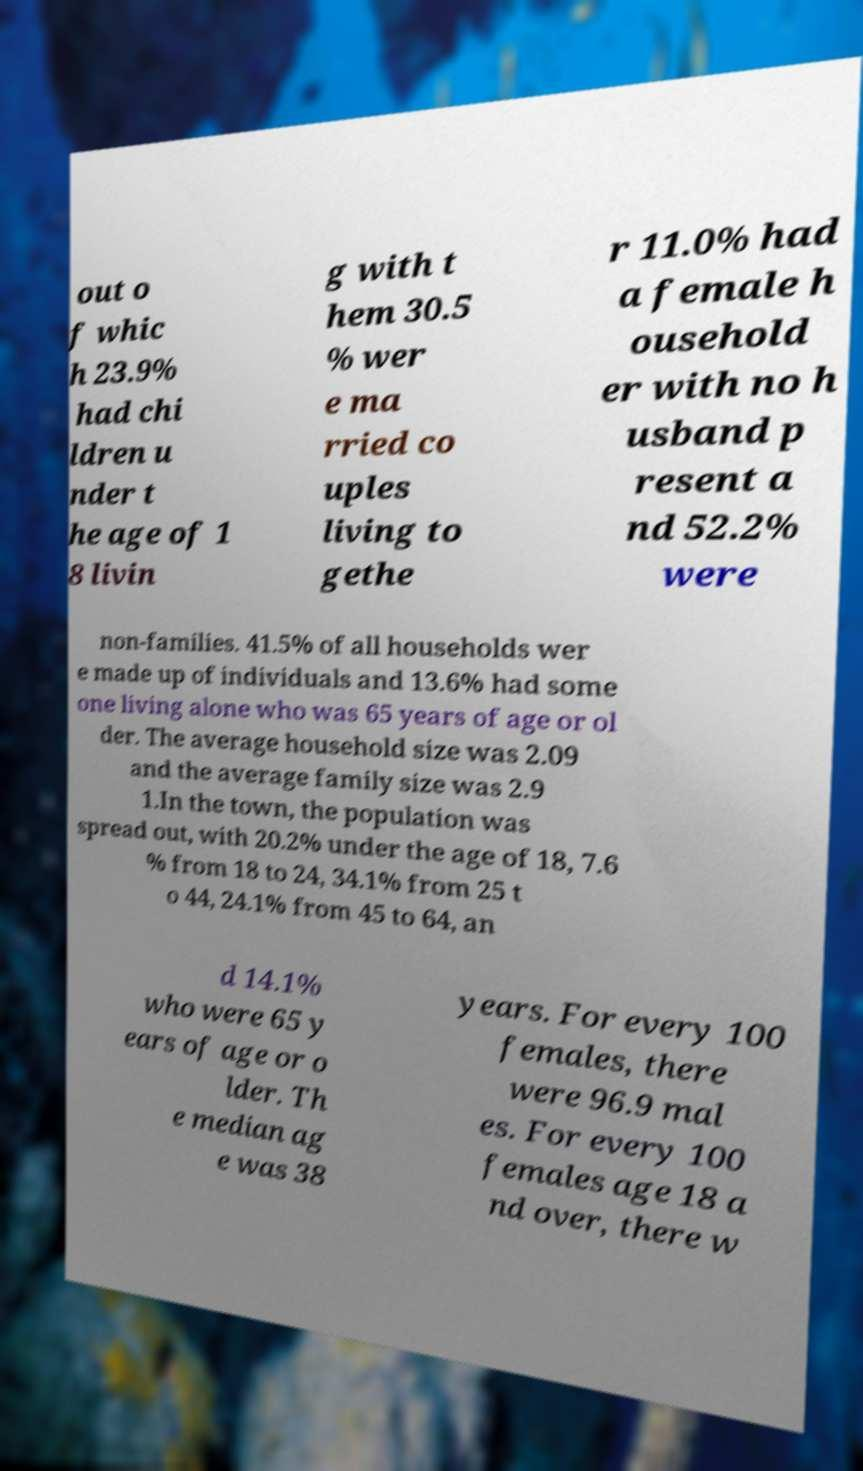I need the written content from this picture converted into text. Can you do that? out o f whic h 23.9% had chi ldren u nder t he age of 1 8 livin g with t hem 30.5 % wer e ma rried co uples living to gethe r 11.0% had a female h ousehold er with no h usband p resent a nd 52.2% were non-families. 41.5% of all households wer e made up of individuals and 13.6% had some one living alone who was 65 years of age or ol der. The average household size was 2.09 and the average family size was 2.9 1.In the town, the population was spread out, with 20.2% under the age of 18, 7.6 % from 18 to 24, 34.1% from 25 t o 44, 24.1% from 45 to 64, an d 14.1% who were 65 y ears of age or o lder. Th e median ag e was 38 years. For every 100 females, there were 96.9 mal es. For every 100 females age 18 a nd over, there w 